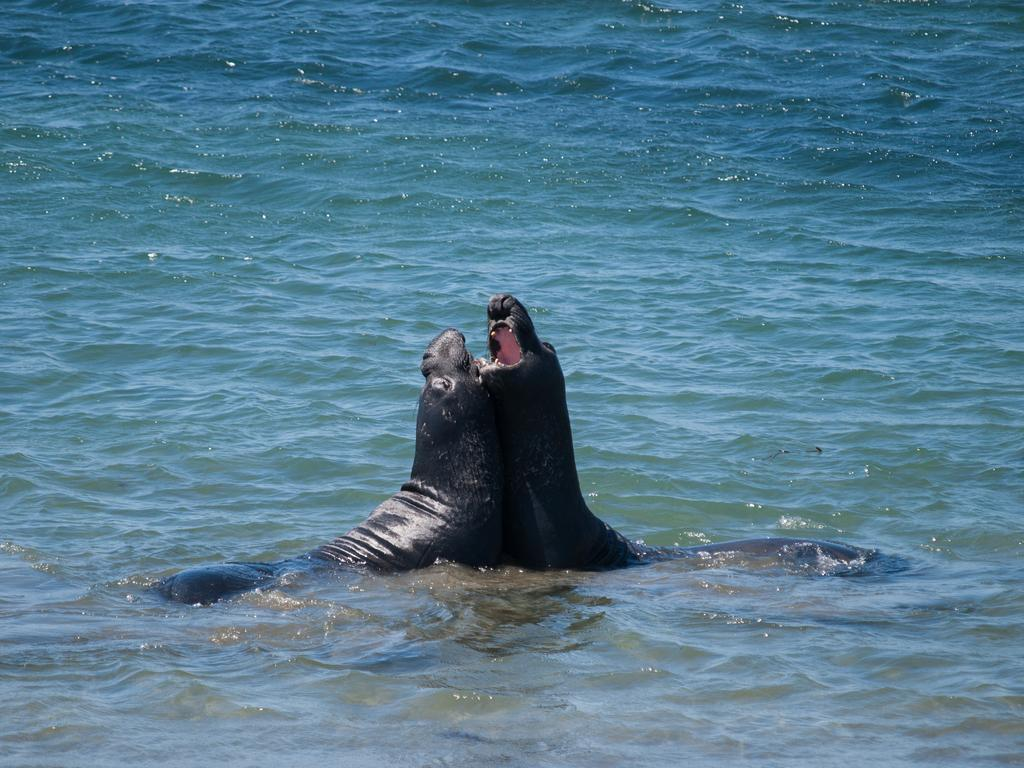What types of animals are in the image? There are two sea animals in the image. How are the sea animals positioned in relation to each other? The sea animals are facing each other. Where are the sea animals located? The sea animals are in the water. What type of apparel is the sea animal wearing in the image? There is no apparel visible on the sea animals in the image, as they are in their natural environment. 